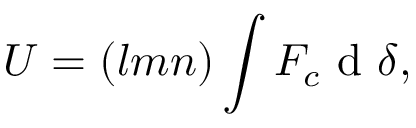Convert formula to latex. <formula><loc_0><loc_0><loc_500><loc_500>U = ( l m n ) \int F _ { c } d { \delta } ,</formula> 